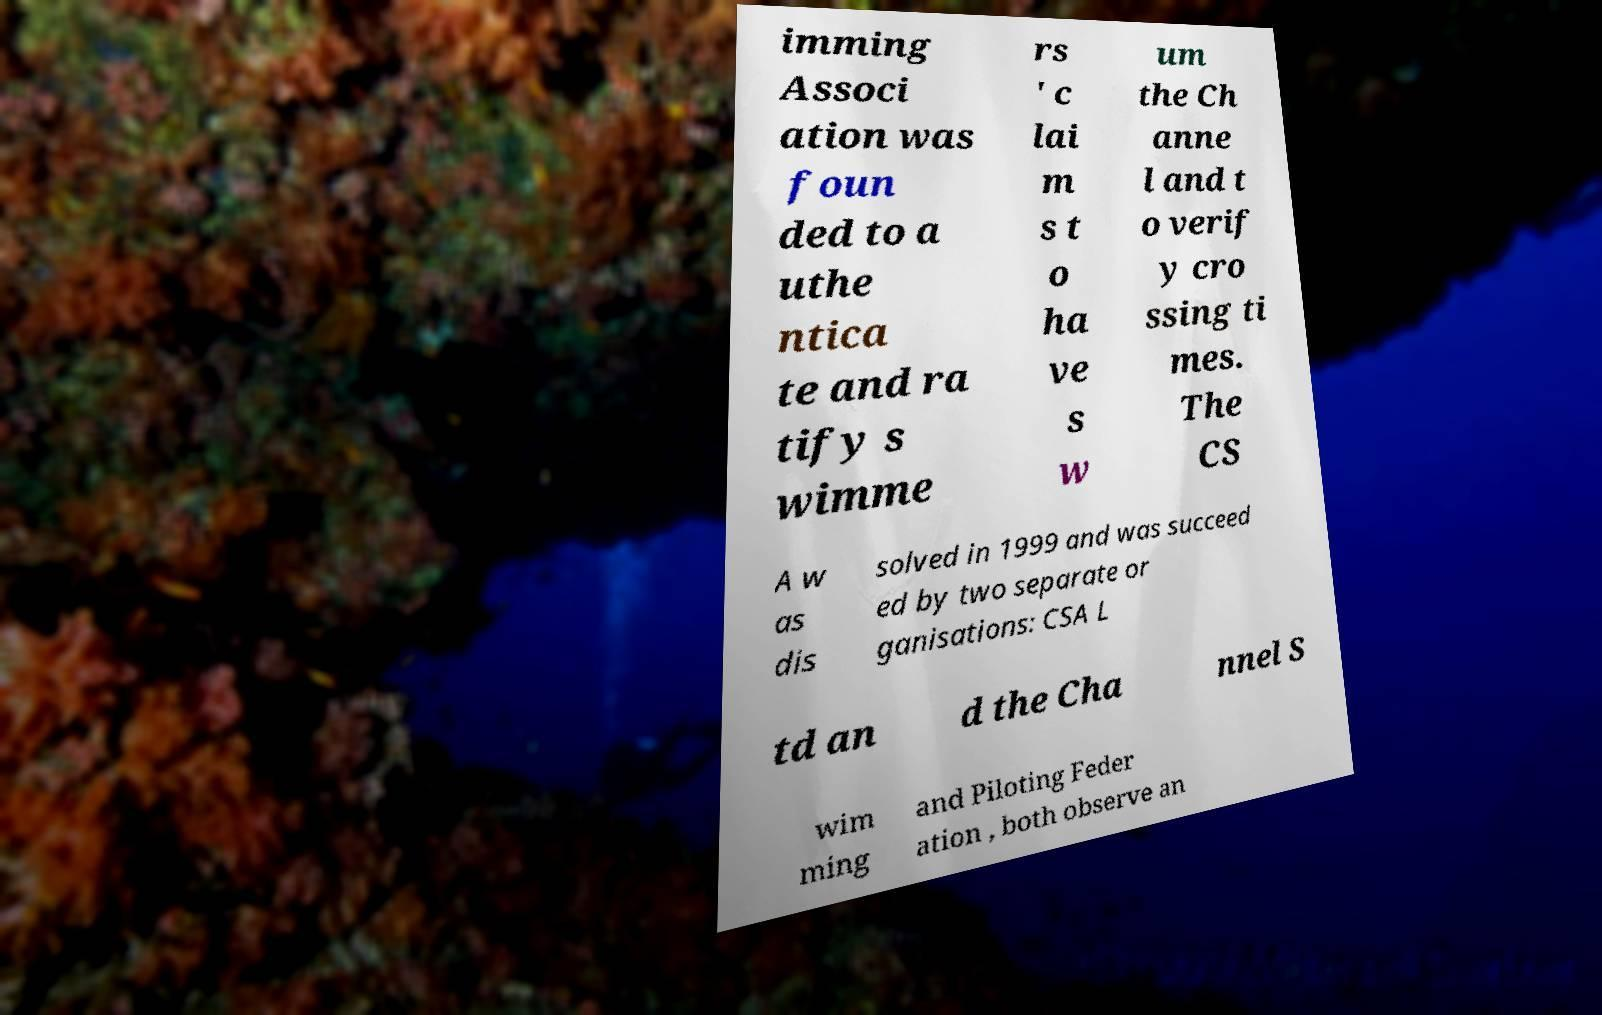What messages or text are displayed in this image? I need them in a readable, typed format. imming Associ ation was foun ded to a uthe ntica te and ra tify s wimme rs ' c lai m s t o ha ve s w um the Ch anne l and t o verif y cro ssing ti mes. The CS A w as dis solved in 1999 and was succeed ed by two separate or ganisations: CSA L td an d the Cha nnel S wim ming and Piloting Feder ation , both observe an 